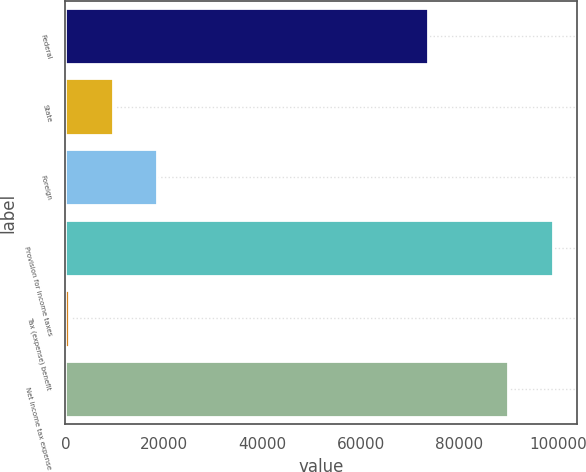<chart> <loc_0><loc_0><loc_500><loc_500><bar_chart><fcel>Federal<fcel>State<fcel>Foreign<fcel>Provision for income taxes<fcel>Tax (expense) benefit<fcel>Net income tax expense<nl><fcel>73562<fcel>9688.8<fcel>18677.6<fcel>98876.8<fcel>700<fcel>89888<nl></chart> 